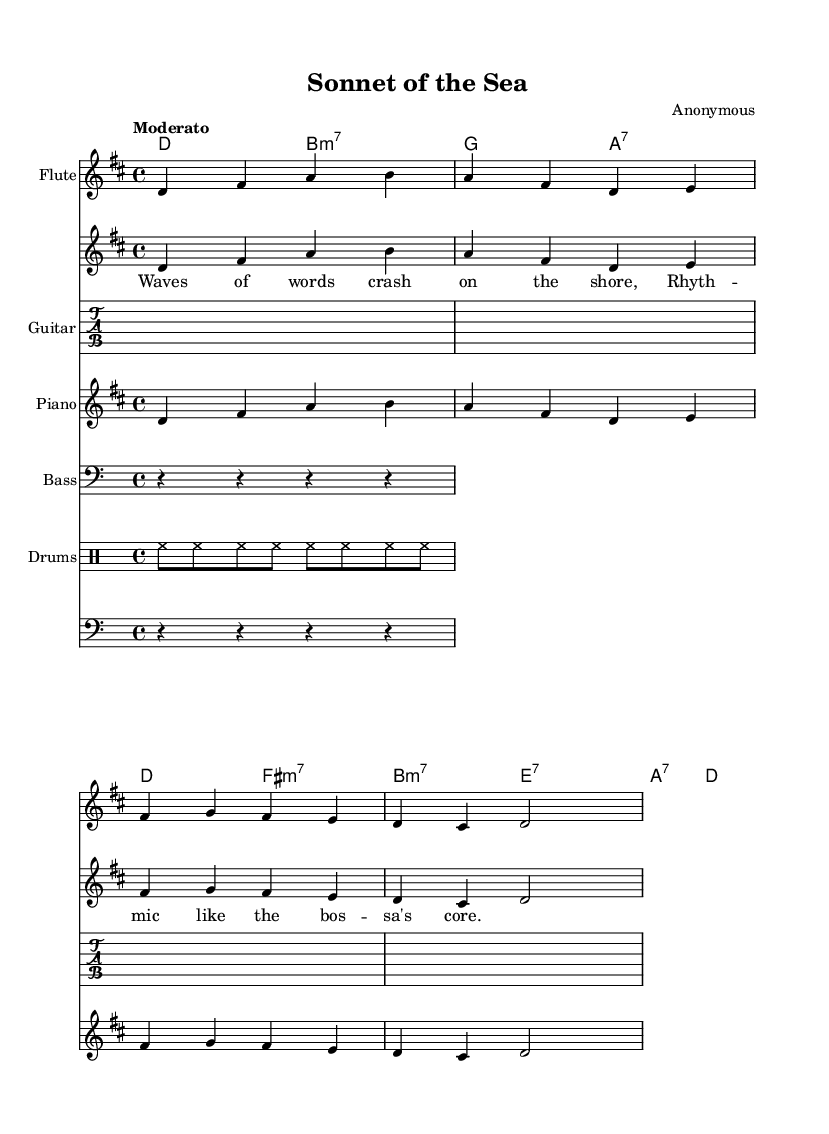What is the key signature of this music? The key signature is D major, which is indicated by the presence of two sharps (F# and C#) in the sheet music.
Answer: D major What is the time signature? The time signature is 4/4, which can be identified at the beginning of the music where the numerals are shown. This means there are four beats per measure.
Answer: 4/4 What is the tempo marking of the piece? The tempo is marked "Moderato," which suggests a moderate speed that is often considered to be around 98-108 beats per minute.
Answer: Moderato How many measures are in the melody? By counting the measures indicated by the vertical bar lines in the melody section of the sheet music, we find there are 6 measures present.
Answer: 6 What type of composition is this? This composition is characterized as a sonnet, indicated by the title "Sonnet of the Sea," a reference suggesting a blend of poetic themes with a musical format.
Answer: Sonnet What instruments are included in this score? The score features multiple instruments: flute, guitar, piano, bass, and drums, all indicated by their respective names at the beginning of each staff.
Answer: Flute, guitar, piano, bass, drums What is the lyrical theme of this piece? The lyrics, "Waves of words crash on the shore, Rhythmic like the bossa's core," indicate a thematic connection to nature and rhythm, which reflects a bossa nova influence.
Answer: Waves and rhythm 